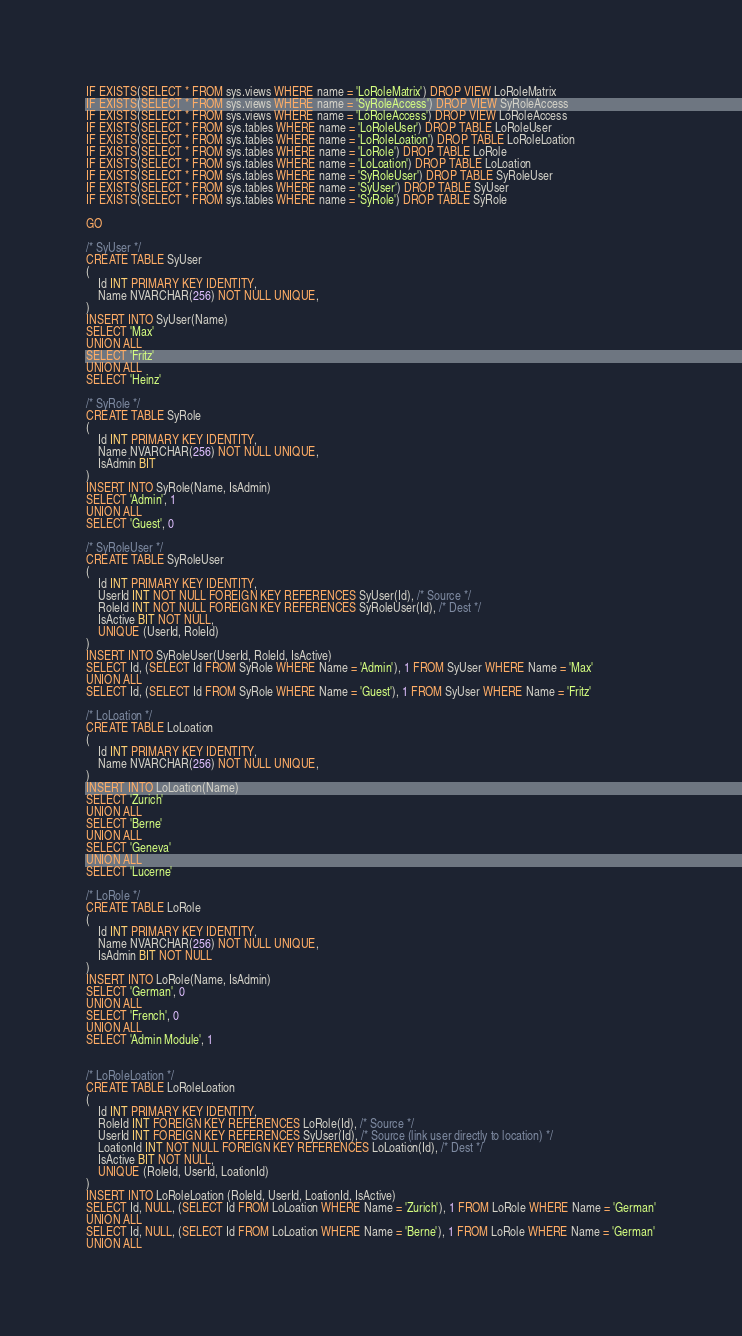Convert code to text. <code><loc_0><loc_0><loc_500><loc_500><_SQL_>IF EXISTS(SELECT * FROM sys.views WHERE name = 'LoRoleMatrix') DROP VIEW LoRoleMatrix
IF EXISTS(SELECT * FROM sys.views WHERE name = 'SyRoleAccess') DROP VIEW SyRoleAccess
IF EXISTS(SELECT * FROM sys.views WHERE name = 'LoRoleAccess') DROP VIEW LoRoleAccess
IF EXISTS(SELECT * FROM sys.tables WHERE name = 'LoRoleUser') DROP TABLE LoRoleUser
IF EXISTS(SELECT * FROM sys.tables WHERE name = 'LoRoleLoation') DROP TABLE LoRoleLoation
IF EXISTS(SELECT * FROM sys.tables WHERE name = 'LoRole') DROP TABLE LoRole
IF EXISTS(SELECT * FROM sys.tables WHERE name = 'LoLoation') DROP TABLE LoLoation
IF EXISTS(SELECT * FROM sys.tables WHERE name = 'SyRoleUser') DROP TABLE SyRoleUser
IF EXISTS(SELECT * FROM sys.tables WHERE name = 'SyUser') DROP TABLE SyUser
IF EXISTS(SELECT * FROM sys.tables WHERE name = 'SyRole') DROP TABLE SyRole

GO

/* SyUser */
CREATE TABLE SyUser
(
	Id INT PRIMARY KEY IDENTITY,
	Name NVARCHAR(256) NOT NULL UNIQUE,
)
INSERT INTO SyUser(Name)
SELECT 'Max'
UNION ALL
SELECT 'Fritz'
UNION ALL
SELECT 'Heinz'

/* SyRole */
CREATE TABLE SyRole
(
	Id INT PRIMARY KEY IDENTITY,
	Name NVARCHAR(256) NOT NULL UNIQUE,
	IsAdmin BIT
)
INSERT INTO SyRole(Name, IsAdmin)
SELECT 'Admin', 1
UNION ALL
SELECT 'Guest', 0

/* SyRoleUser */
CREATE TABLE SyRoleUser
(
	Id INT PRIMARY KEY IDENTITY,
	UserId INT NOT NULL FOREIGN KEY REFERENCES SyUser(Id), /* Source */
	RoleId INT NOT NULL FOREIGN KEY REFERENCES SyRoleUser(Id), /* Dest */
	IsActive BIT NOT NULL,
	UNIQUE (UserId, RoleId)
)
INSERT INTO SyRoleUser(UserId, RoleId, IsActive)
SELECT Id, (SELECT Id FROM SyRole WHERE Name = 'Admin'), 1 FROM SyUser WHERE Name = 'Max'
UNION ALL
SELECT Id, (SELECT Id FROM SyRole WHERE Name = 'Guest'), 1 FROM SyUser WHERE Name = 'Fritz'

/* LoLoation */
CREATE TABLE LoLoation
(
	Id INT PRIMARY KEY IDENTITY,
	Name NVARCHAR(256) NOT NULL UNIQUE,
)
INSERT INTO LoLoation(Name)
SELECT 'Zurich'
UNION ALL
SELECT 'Berne'
UNION ALL
SELECT 'Geneva'
UNION ALL
SELECT 'Lucerne'

/* LoRole */
CREATE TABLE LoRole
(
	Id INT PRIMARY KEY IDENTITY,
	Name NVARCHAR(256) NOT NULL UNIQUE,
	IsAdmin BIT NOT NULL
)
INSERT INTO LoRole(Name, IsAdmin)
SELECT 'German', 0
UNION ALL
SELECT 'French', 0
UNION ALL
SELECT 'Admin Module', 1


/* LoRoleLoation */
CREATE TABLE LoRoleLoation
(
	Id INT PRIMARY KEY IDENTITY,
	RoleId INT FOREIGN KEY REFERENCES LoRole(Id), /* Source */
	UserId INT FOREIGN KEY REFERENCES SyUser(Id), /* Source (link user directly to location) */
	LoationId INT NOT NULL FOREIGN KEY REFERENCES LoLoation(Id), /* Dest */
	IsActive BIT NOT NULL,
	UNIQUE (RoleId, UserId, LoationId)
)
INSERT INTO LoRoleLoation (RoleId, UserId, LoationId, IsActive)
SELECT Id, NULL, (SELECT Id FROM LoLoation WHERE Name = 'Zurich'), 1 FROM LoRole WHERE Name = 'German'
UNION ALL
SELECT Id, NULL, (SELECT Id FROM LoLoation WHERE Name = 'Berne'), 1 FROM LoRole WHERE Name = 'German'
UNION ALL</code> 